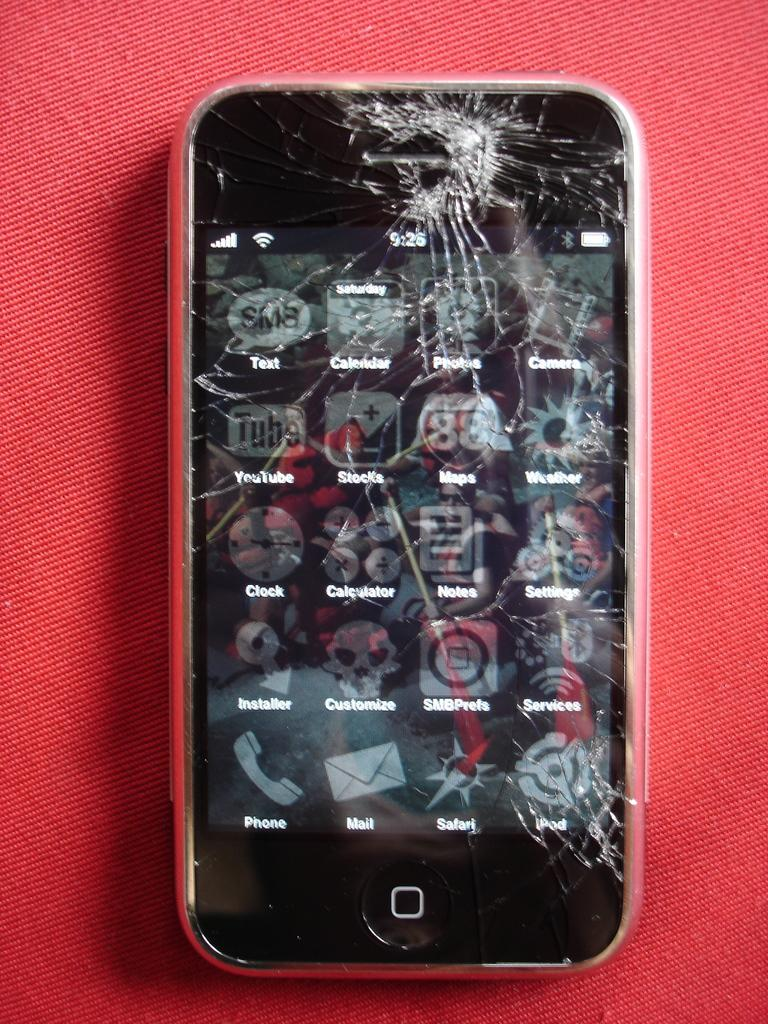<image>
Relay a brief, clear account of the picture shown. A cracked cell phone screen with YouTube installed on it. 